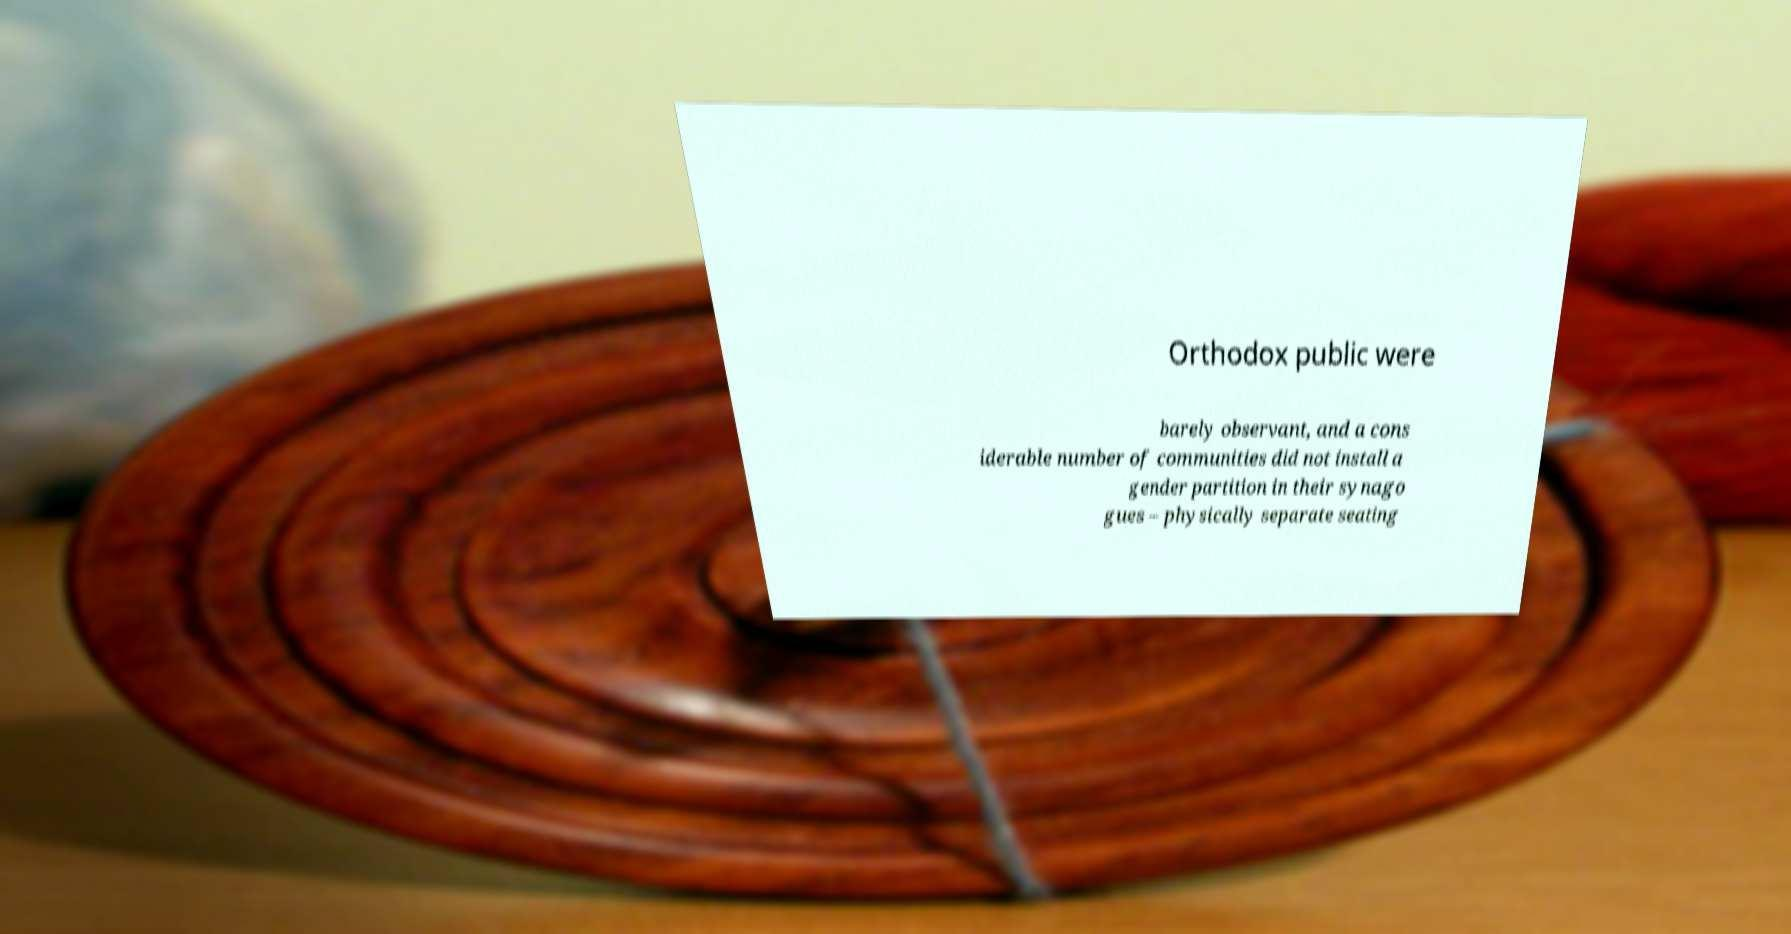Can you accurately transcribe the text from the provided image for me? Orthodox public were barely observant, and a cons iderable number of communities did not install a gender partition in their synago gues – physically separate seating 